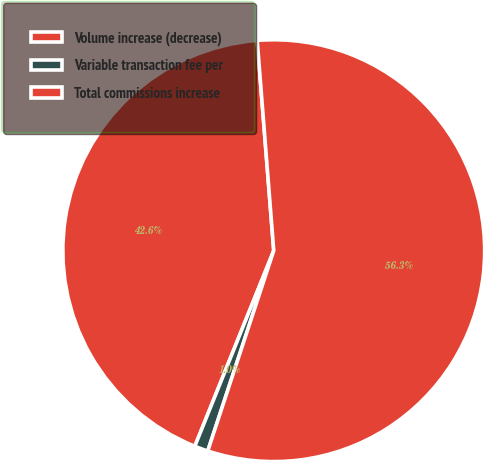<chart> <loc_0><loc_0><loc_500><loc_500><pie_chart><fcel>Volume increase (decrease)<fcel>Variable transaction fee per<fcel>Total commissions increase<nl><fcel>42.65%<fcel>1.04%<fcel>56.32%<nl></chart> 